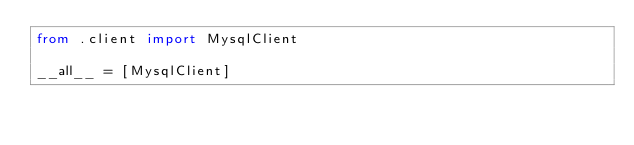Convert code to text. <code><loc_0><loc_0><loc_500><loc_500><_Python_>from .client import MysqlClient

__all__ = [MysqlClient]
</code> 